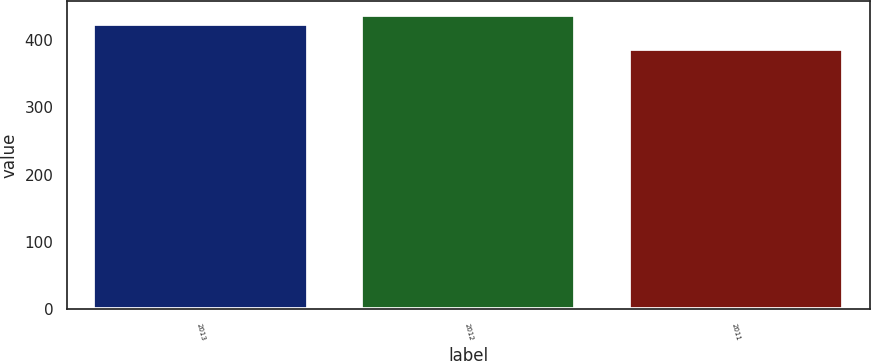Convert chart. <chart><loc_0><loc_0><loc_500><loc_500><bar_chart><fcel>2013<fcel>2012<fcel>2011<nl><fcel>424<fcel>437<fcel>387<nl></chart> 